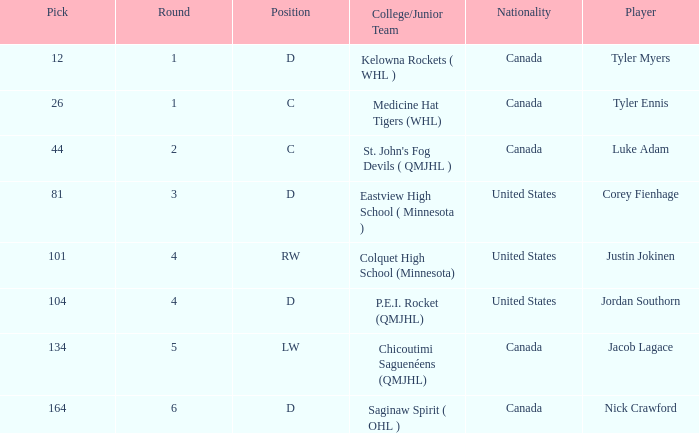What is the college/junior team of player tyler myers, who has a pick less than 44? Kelowna Rockets ( WHL ). 